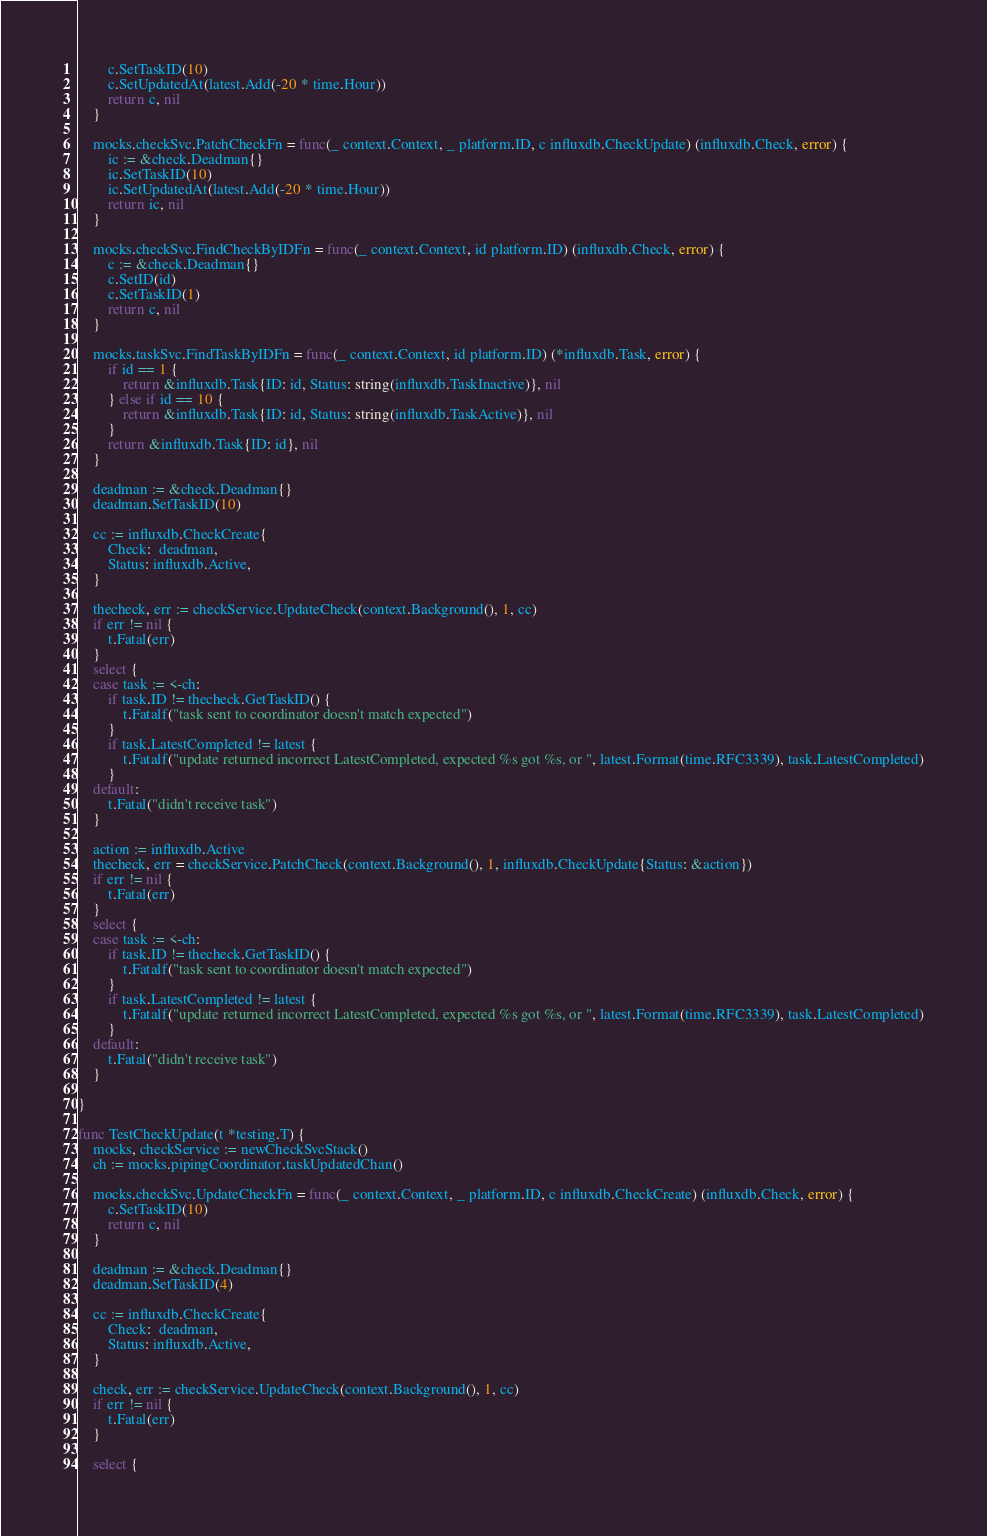Convert code to text. <code><loc_0><loc_0><loc_500><loc_500><_Go_>		c.SetTaskID(10)
		c.SetUpdatedAt(latest.Add(-20 * time.Hour))
		return c, nil
	}

	mocks.checkSvc.PatchCheckFn = func(_ context.Context, _ platform.ID, c influxdb.CheckUpdate) (influxdb.Check, error) {
		ic := &check.Deadman{}
		ic.SetTaskID(10)
		ic.SetUpdatedAt(latest.Add(-20 * time.Hour))
		return ic, nil
	}

	mocks.checkSvc.FindCheckByIDFn = func(_ context.Context, id platform.ID) (influxdb.Check, error) {
		c := &check.Deadman{}
		c.SetID(id)
		c.SetTaskID(1)
		return c, nil
	}

	mocks.taskSvc.FindTaskByIDFn = func(_ context.Context, id platform.ID) (*influxdb.Task, error) {
		if id == 1 {
			return &influxdb.Task{ID: id, Status: string(influxdb.TaskInactive)}, nil
		} else if id == 10 {
			return &influxdb.Task{ID: id, Status: string(influxdb.TaskActive)}, nil
		}
		return &influxdb.Task{ID: id}, nil
	}

	deadman := &check.Deadman{}
	deadman.SetTaskID(10)

	cc := influxdb.CheckCreate{
		Check:  deadman,
		Status: influxdb.Active,
	}

	thecheck, err := checkService.UpdateCheck(context.Background(), 1, cc)
	if err != nil {
		t.Fatal(err)
	}
	select {
	case task := <-ch:
		if task.ID != thecheck.GetTaskID() {
			t.Fatalf("task sent to coordinator doesn't match expected")
		}
		if task.LatestCompleted != latest {
			t.Fatalf("update returned incorrect LatestCompleted, expected %s got %s, or ", latest.Format(time.RFC3339), task.LatestCompleted)
		}
	default:
		t.Fatal("didn't receive task")
	}

	action := influxdb.Active
	thecheck, err = checkService.PatchCheck(context.Background(), 1, influxdb.CheckUpdate{Status: &action})
	if err != nil {
		t.Fatal(err)
	}
	select {
	case task := <-ch:
		if task.ID != thecheck.GetTaskID() {
			t.Fatalf("task sent to coordinator doesn't match expected")
		}
		if task.LatestCompleted != latest {
			t.Fatalf("update returned incorrect LatestCompleted, expected %s got %s, or ", latest.Format(time.RFC3339), task.LatestCompleted)
		}
	default:
		t.Fatal("didn't receive task")
	}

}

func TestCheckUpdate(t *testing.T) {
	mocks, checkService := newCheckSvcStack()
	ch := mocks.pipingCoordinator.taskUpdatedChan()

	mocks.checkSvc.UpdateCheckFn = func(_ context.Context, _ platform.ID, c influxdb.CheckCreate) (influxdb.Check, error) {
		c.SetTaskID(10)
		return c, nil
	}

	deadman := &check.Deadman{}
	deadman.SetTaskID(4)

	cc := influxdb.CheckCreate{
		Check:  deadman,
		Status: influxdb.Active,
	}

	check, err := checkService.UpdateCheck(context.Background(), 1, cc)
	if err != nil {
		t.Fatal(err)
	}

	select {</code> 